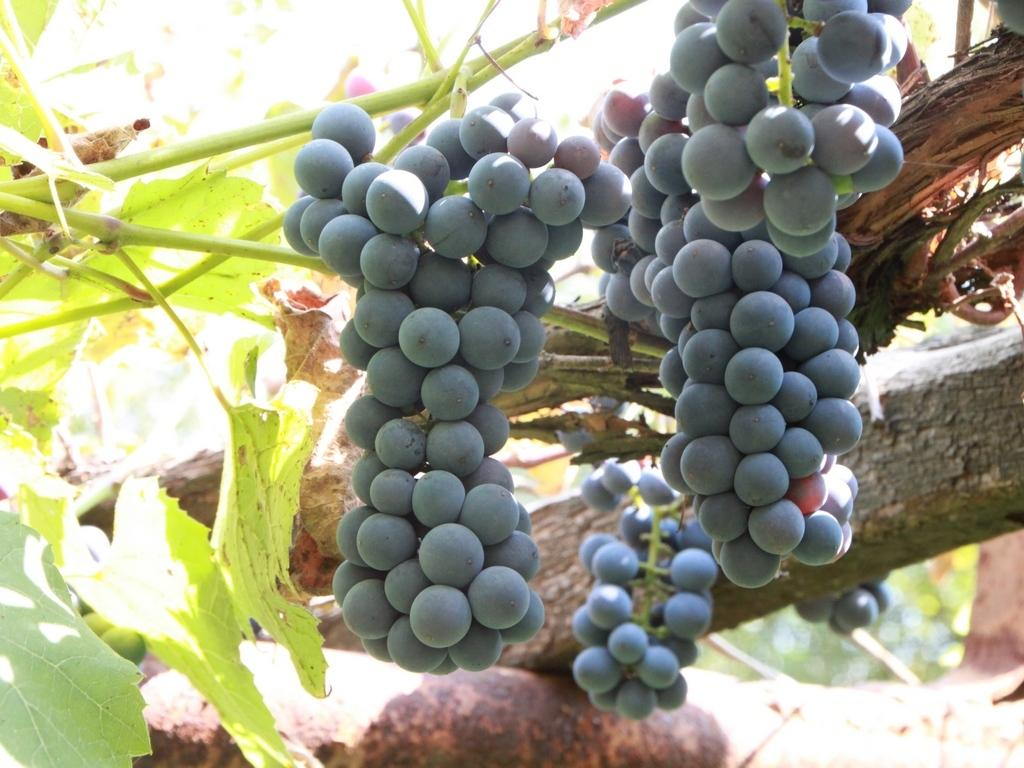What type of fruit can be seen in the image? There is a bunch of grapes in the image. Where are the grapes located on the tree? The grapes are on the branch of a tree. What color are the leaves on the tree? The tree has green leaves. What type of hammer is being used to tell a story about the grapes in the image? There is no hammer or story present in the image; it features a bunch of grapes on the branch of a tree with green leaves. 